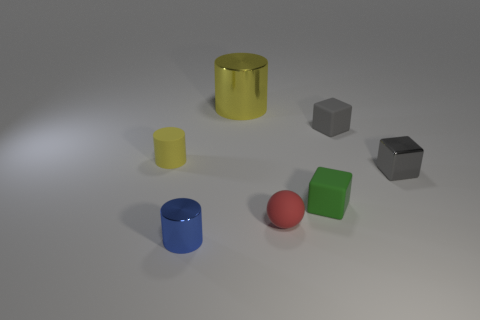Is the color of the large shiny cylinder the same as the tiny matte cylinder?
Ensure brevity in your answer.  Yes. Are there any other things that are the same size as the yellow metallic cylinder?
Make the answer very short. No. What shape is the object that is both behind the matte cylinder and right of the red ball?
Make the answer very short. Cube. There is a large shiny thing; is it the same color as the small metallic object that is right of the yellow metallic object?
Provide a succinct answer. No. What color is the small metal object left of the yellow object on the right side of the small shiny thing left of the large metal cylinder?
Give a very brief answer. Blue. What color is the rubber object that is the same shape as the blue metal thing?
Your response must be concise. Yellow. Are there the same number of tiny blue cylinders that are in front of the tiny blue cylinder and large blue balls?
Offer a very short reply. Yes. What number of blocks are small shiny things or yellow rubber objects?
Your answer should be very brief. 1. There is a cylinder that is made of the same material as the green object; what is its color?
Give a very brief answer. Yellow. Does the red sphere have the same material as the small cylinder behind the tiny green block?
Give a very brief answer. Yes. 